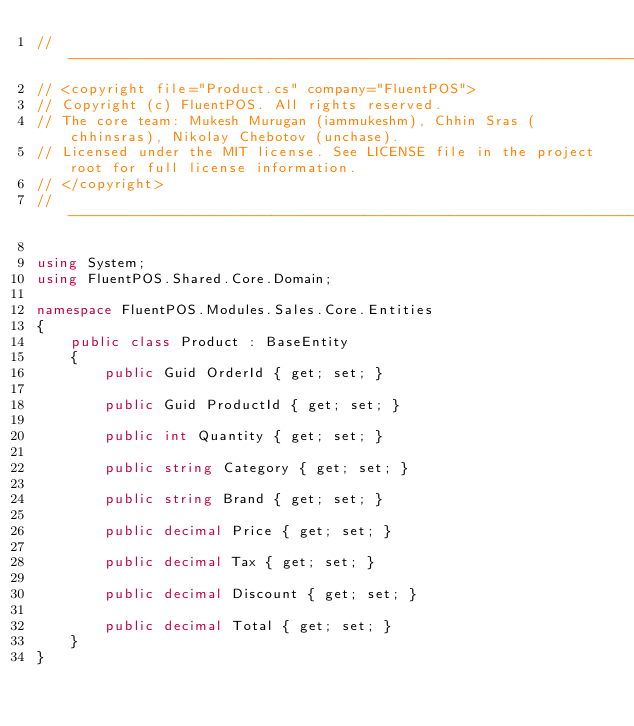Convert code to text. <code><loc_0><loc_0><loc_500><loc_500><_C#_>// --------------------------------------------------------------------------------------------------
// <copyright file="Product.cs" company="FluentPOS">
// Copyright (c) FluentPOS. All rights reserved.
// The core team: Mukesh Murugan (iammukeshm), Chhin Sras (chhinsras), Nikolay Chebotov (unchase).
// Licensed under the MIT license. See LICENSE file in the project root for full license information.
// </copyright>
// --------------------------------------------------------------------------------------------------

using System;
using FluentPOS.Shared.Core.Domain;

namespace FluentPOS.Modules.Sales.Core.Entities
{
    public class Product : BaseEntity
    {
        public Guid OrderId { get; set; }

        public Guid ProductId { get; set; }

        public int Quantity { get; set; }

        public string Category { get; set; }

        public string Brand { get; set; }

        public decimal Price { get; set; }

        public decimal Tax { get; set; }

        public decimal Discount { get; set; }

        public decimal Total { get; set; }
    }
}</code> 